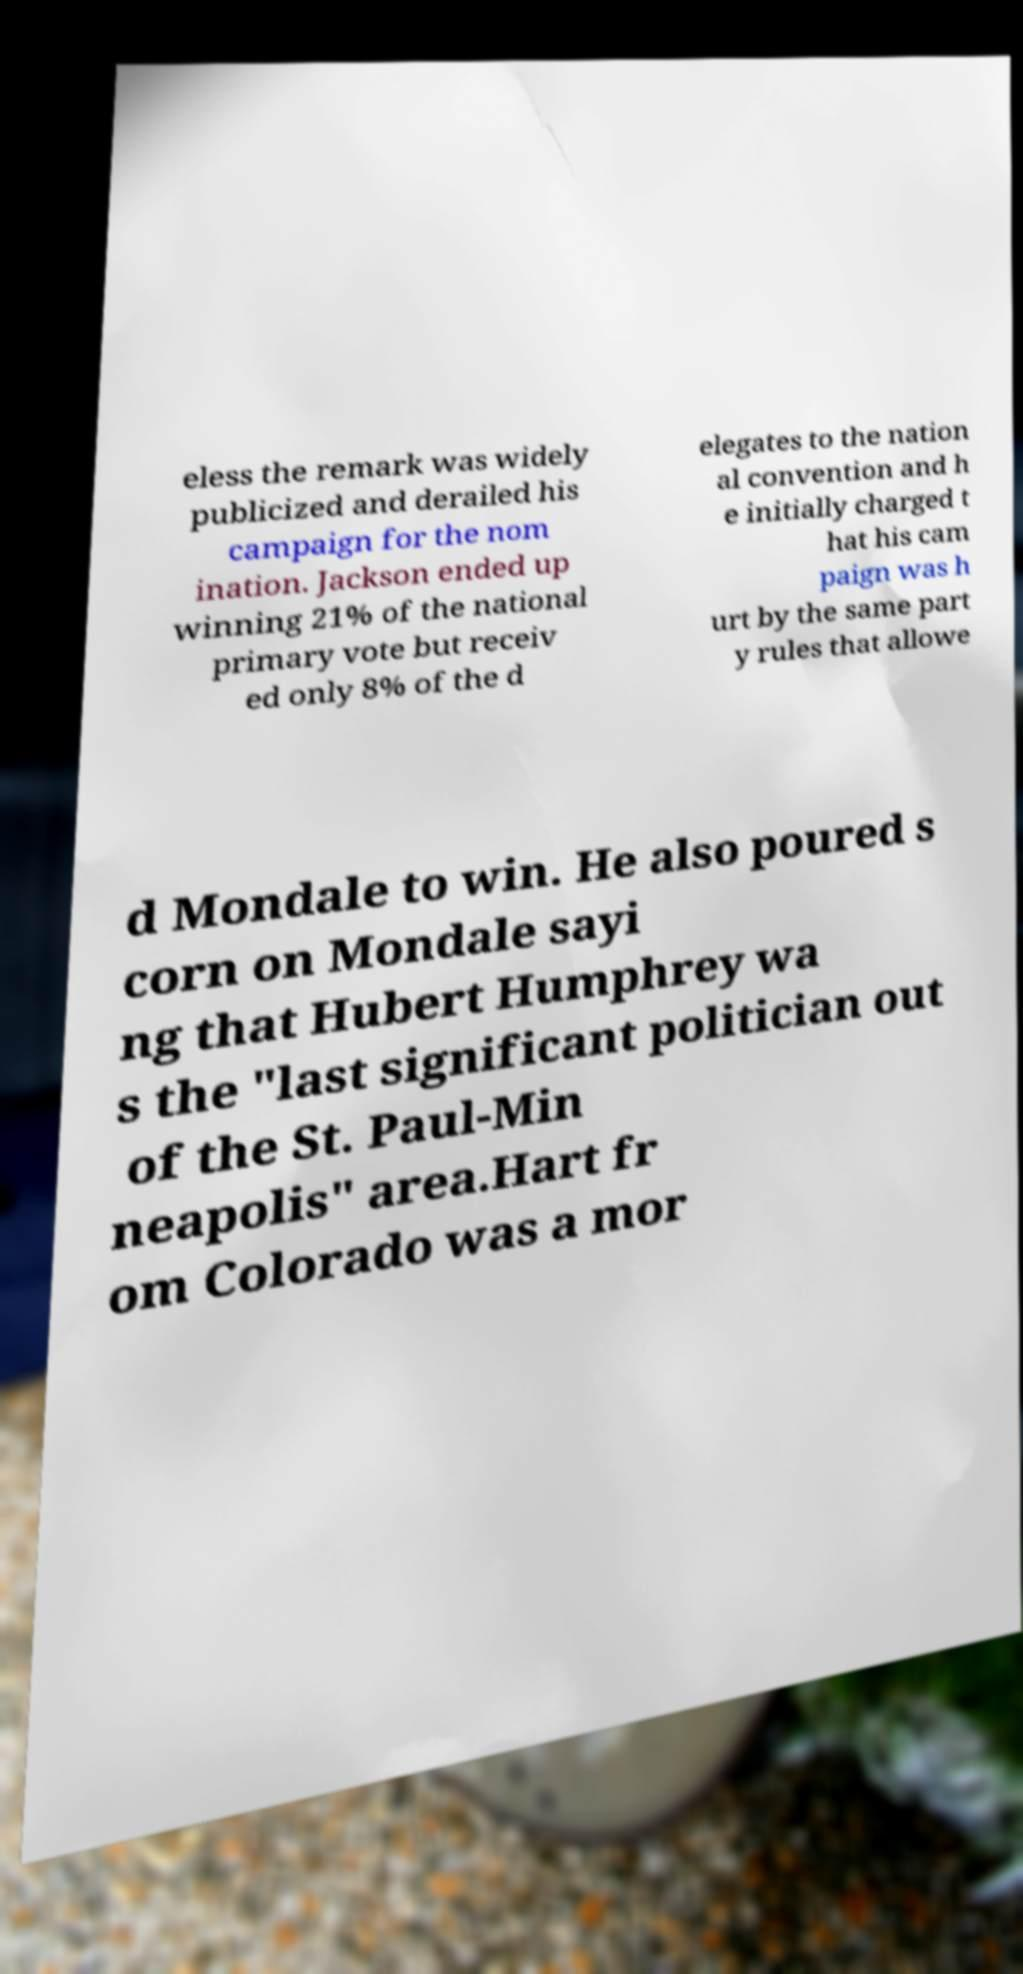Can you accurately transcribe the text from the provided image for me? eless the remark was widely publicized and derailed his campaign for the nom ination. Jackson ended up winning 21% of the national primary vote but receiv ed only 8% of the d elegates to the nation al convention and h e initially charged t hat his cam paign was h urt by the same part y rules that allowe d Mondale to win. He also poured s corn on Mondale sayi ng that Hubert Humphrey wa s the "last significant politician out of the St. Paul-Min neapolis" area.Hart fr om Colorado was a mor 